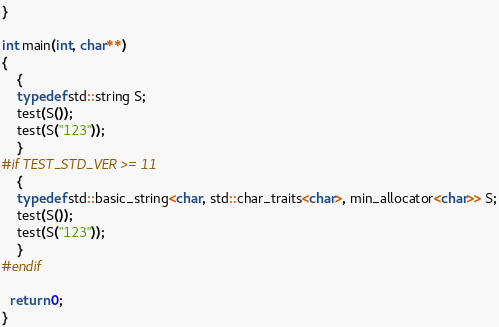<code> <loc_0><loc_0><loc_500><loc_500><_C++_>}

int main(int, char**)
{
    {
    typedef std::string S;
    test(S());
    test(S("123"));
    }
#if TEST_STD_VER >= 11
    {
    typedef std::basic_string<char, std::char_traits<char>, min_allocator<char>> S;
    test(S());
    test(S("123"));
    }
#endif

  return 0;
}
</code> 